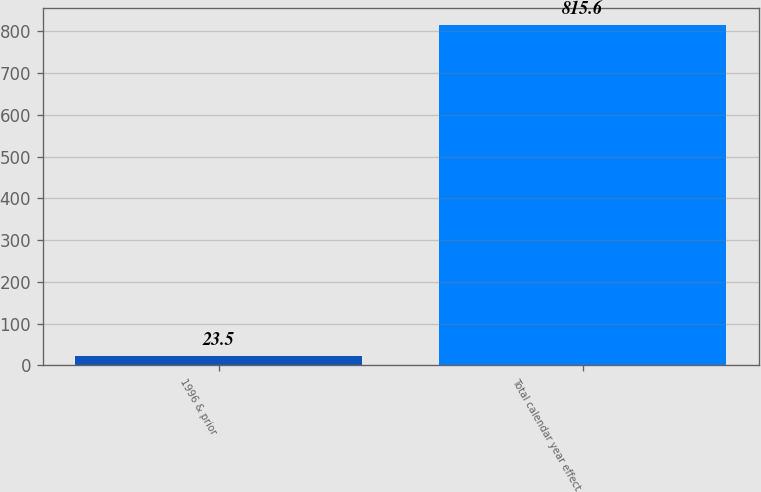<chart> <loc_0><loc_0><loc_500><loc_500><bar_chart><fcel>1996 & prior<fcel>Total calendar year effect<nl><fcel>23.5<fcel>815.6<nl></chart> 